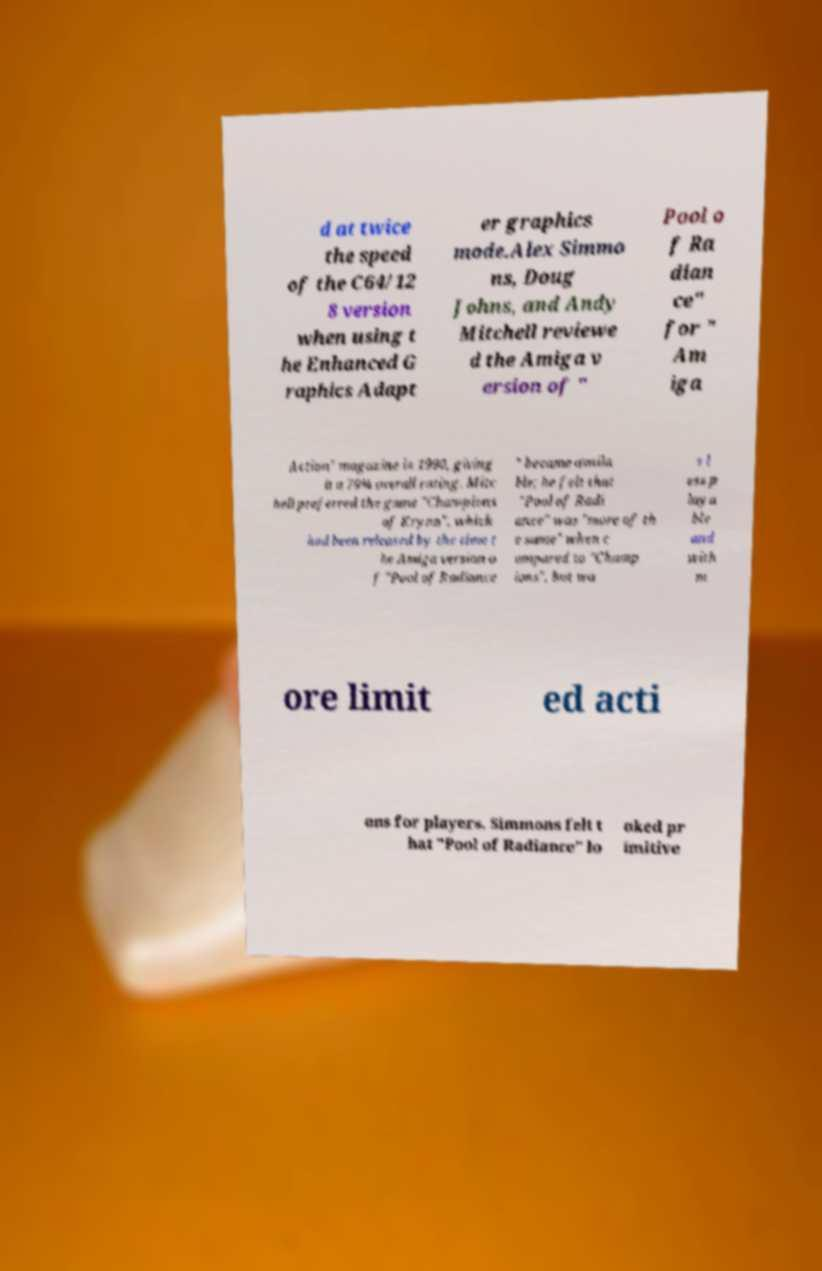Could you assist in decoding the text presented in this image and type it out clearly? d at twice the speed of the C64/12 8 version when using t he Enhanced G raphics Adapt er graphics mode.Alex Simmo ns, Doug Johns, and Andy Mitchell reviewe d the Amiga v ersion of " Pool o f Ra dian ce" for " Am iga Action" magazine in 1990, giving it a 79% overall rating. Mitc hell preferred the game "Champions of Krynn", which had been released by the time t he Amiga version o f "Pool of Radiance " became availa ble; he felt that "Pool of Radi ance" was "more of th e same" when c ompared to "Champ ions", but wa s l ess p laya ble and with m ore limit ed acti ons for players. Simmons felt t hat "Pool of Radiance" lo oked pr imitive 